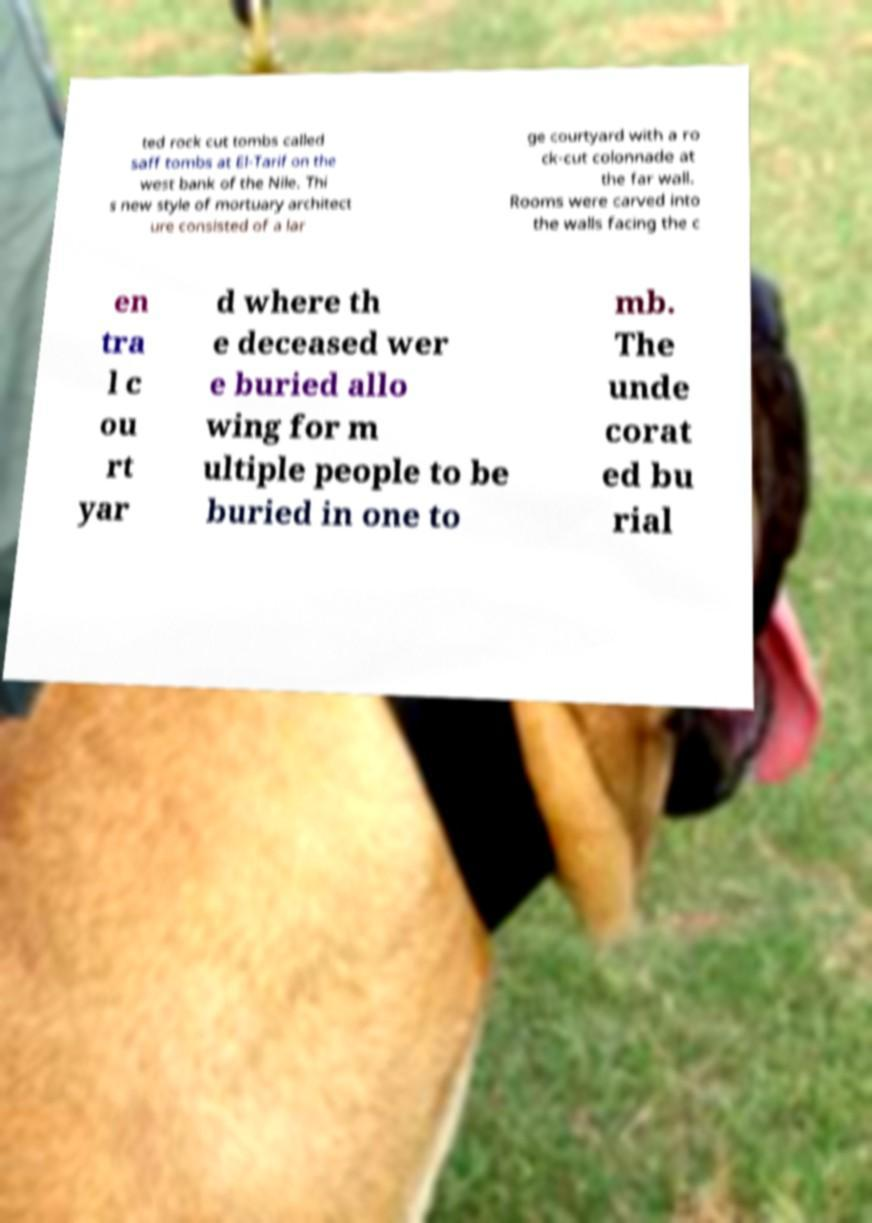Can you accurately transcribe the text from the provided image for me? ted rock cut tombs called saff tombs at El-Tarif on the west bank of the Nile. Thi s new style of mortuary architect ure consisted of a lar ge courtyard with a ro ck-cut colonnade at the far wall. Rooms were carved into the walls facing the c en tra l c ou rt yar d where th e deceased wer e buried allo wing for m ultiple people to be buried in one to mb. The unde corat ed bu rial 